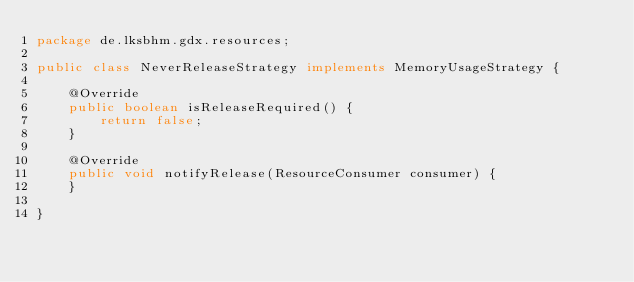<code> <loc_0><loc_0><loc_500><loc_500><_Java_>package de.lksbhm.gdx.resources;

public class NeverReleaseStrategy implements MemoryUsageStrategy {

	@Override
	public boolean isReleaseRequired() {
		return false;
	}

	@Override
	public void notifyRelease(ResourceConsumer consumer) {
	}

}
</code> 